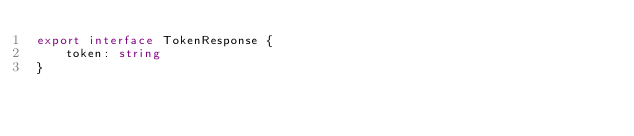Convert code to text. <code><loc_0><loc_0><loc_500><loc_500><_TypeScript_>export interface TokenResponse {
    token: string
}</code> 